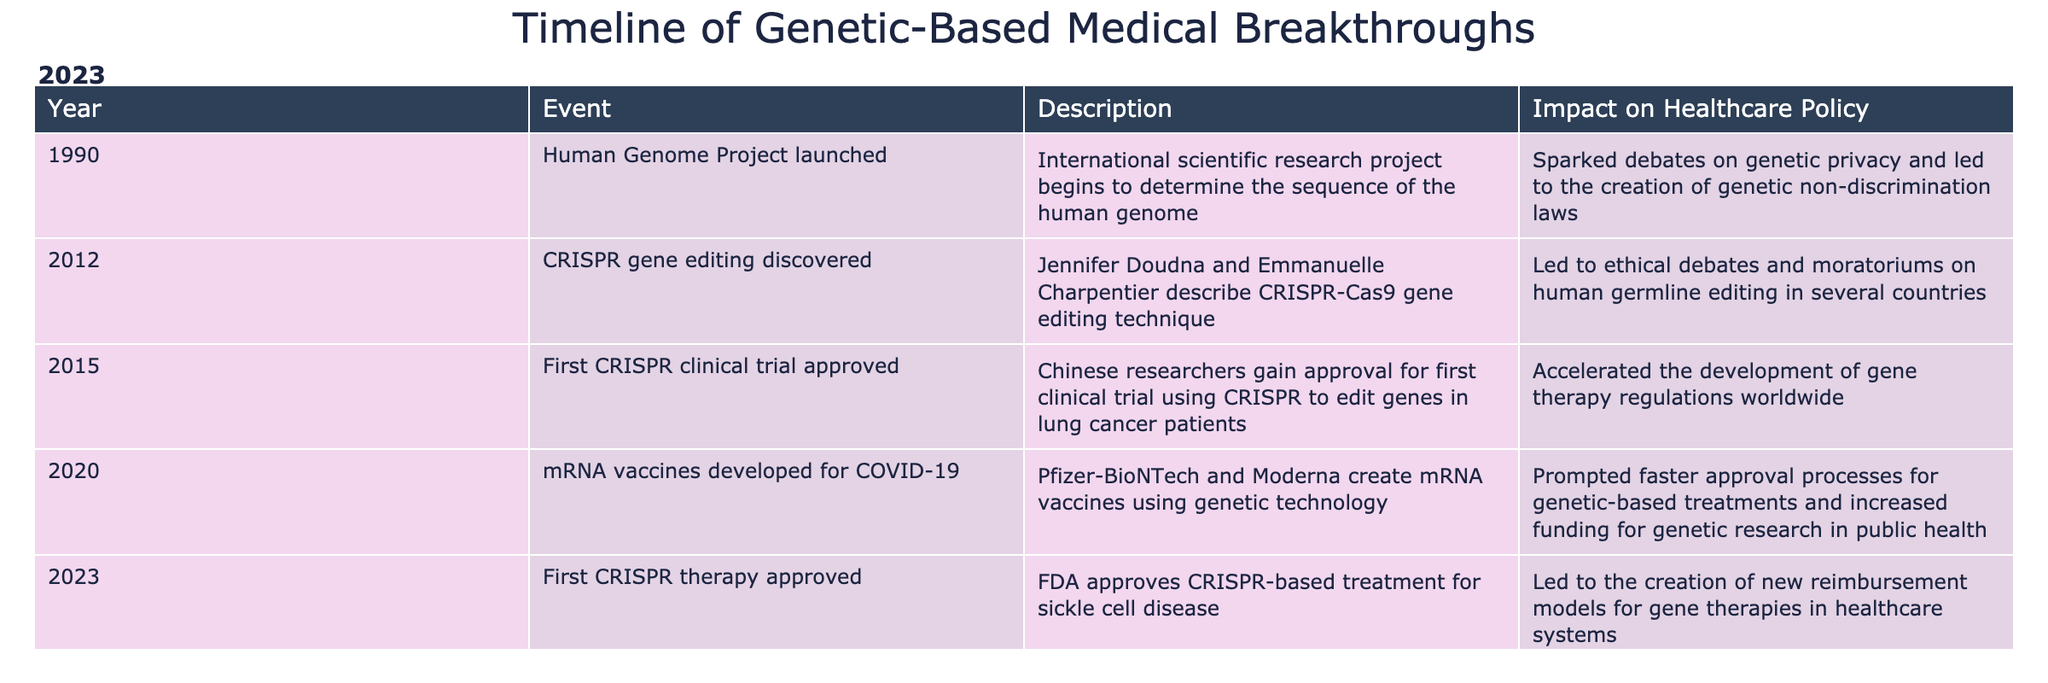What year was the Human Genome Project launched? The table indicates the Human Genome Project was launched in the year 1990.
Answer: 1990 How many events occurred by the year 2020? The table lists five events; 1990, 2012, 2015, 2020, and 2023. Therefore, by the year 2020, there are four events (1990, 2012, 2015, 2020).
Answer: 4 Did the discovery of CRISPR gene editing lead to any regulatory changes? Yes, the description of the CRISPR gene editing discovery in 2012 mentions it led to ethical debates and moratoriums on human germline editing in several countries, indicating regulatory changes.
Answer: Yes What is the impact on healthcare policy from the mRNA vaccines developed in 2020? The mRNA vaccines developed in 2020 prompted faster approval processes for genetic-based treatments and increased funding for genetic research in public health. This information can be found in the impact column corresponding to the year 2020.
Answer: Faster approval processes and increased funding Which event had the most recent impact on healthcare policy? The table lists that the first CRISPR therapy approval occurred in 2023 and it led to the creation of new reimbursement models for gene therapies, making it the most recent impact on healthcare policy.
Answer: 2023 What was the primary effect on healthcare policy resulting from the Human Genome Project? According to the table, the Human Genome Project sparked debates on genetic privacy and led to the creation of genetic non-discrimination laws. This refers to its significant impact on healthcare policy.
Answer: Genetic non-discrimination laws 